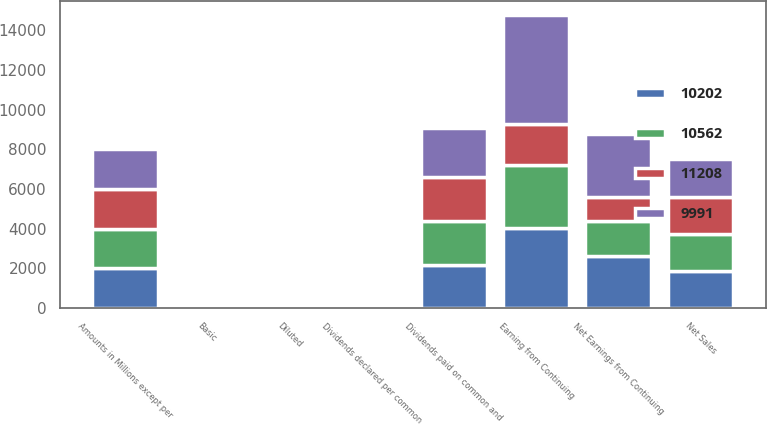<chart> <loc_0><loc_0><loc_500><loc_500><stacked_bar_chart><ecel><fcel>Amounts in Millions except per<fcel>Net Sales<fcel>Earning from Continuing<fcel>Net Earnings from Continuing<fcel>Basic<fcel>Diluted<fcel>Dividends paid on common and<fcel>Dividends declared per common<nl><fcel>9991<fcel>2008<fcel>1873<fcel>5471<fcel>3155<fcel>1.6<fcel>1.59<fcel>2461<fcel>1.24<nl><fcel>10562<fcel>2007<fcel>1873<fcel>3186<fcel>1741<fcel>0.88<fcel>0.88<fcel>2213<fcel>1.15<nl><fcel>11208<fcel>2006<fcel>1873<fcel>2085<fcel>1214<fcel>0.62<fcel>0.62<fcel>2199<fcel>1.12<nl><fcel>10202<fcel>2005<fcel>1873<fcel>4016<fcel>2652<fcel>1.36<fcel>1.35<fcel>2186<fcel>1.12<nl></chart> 